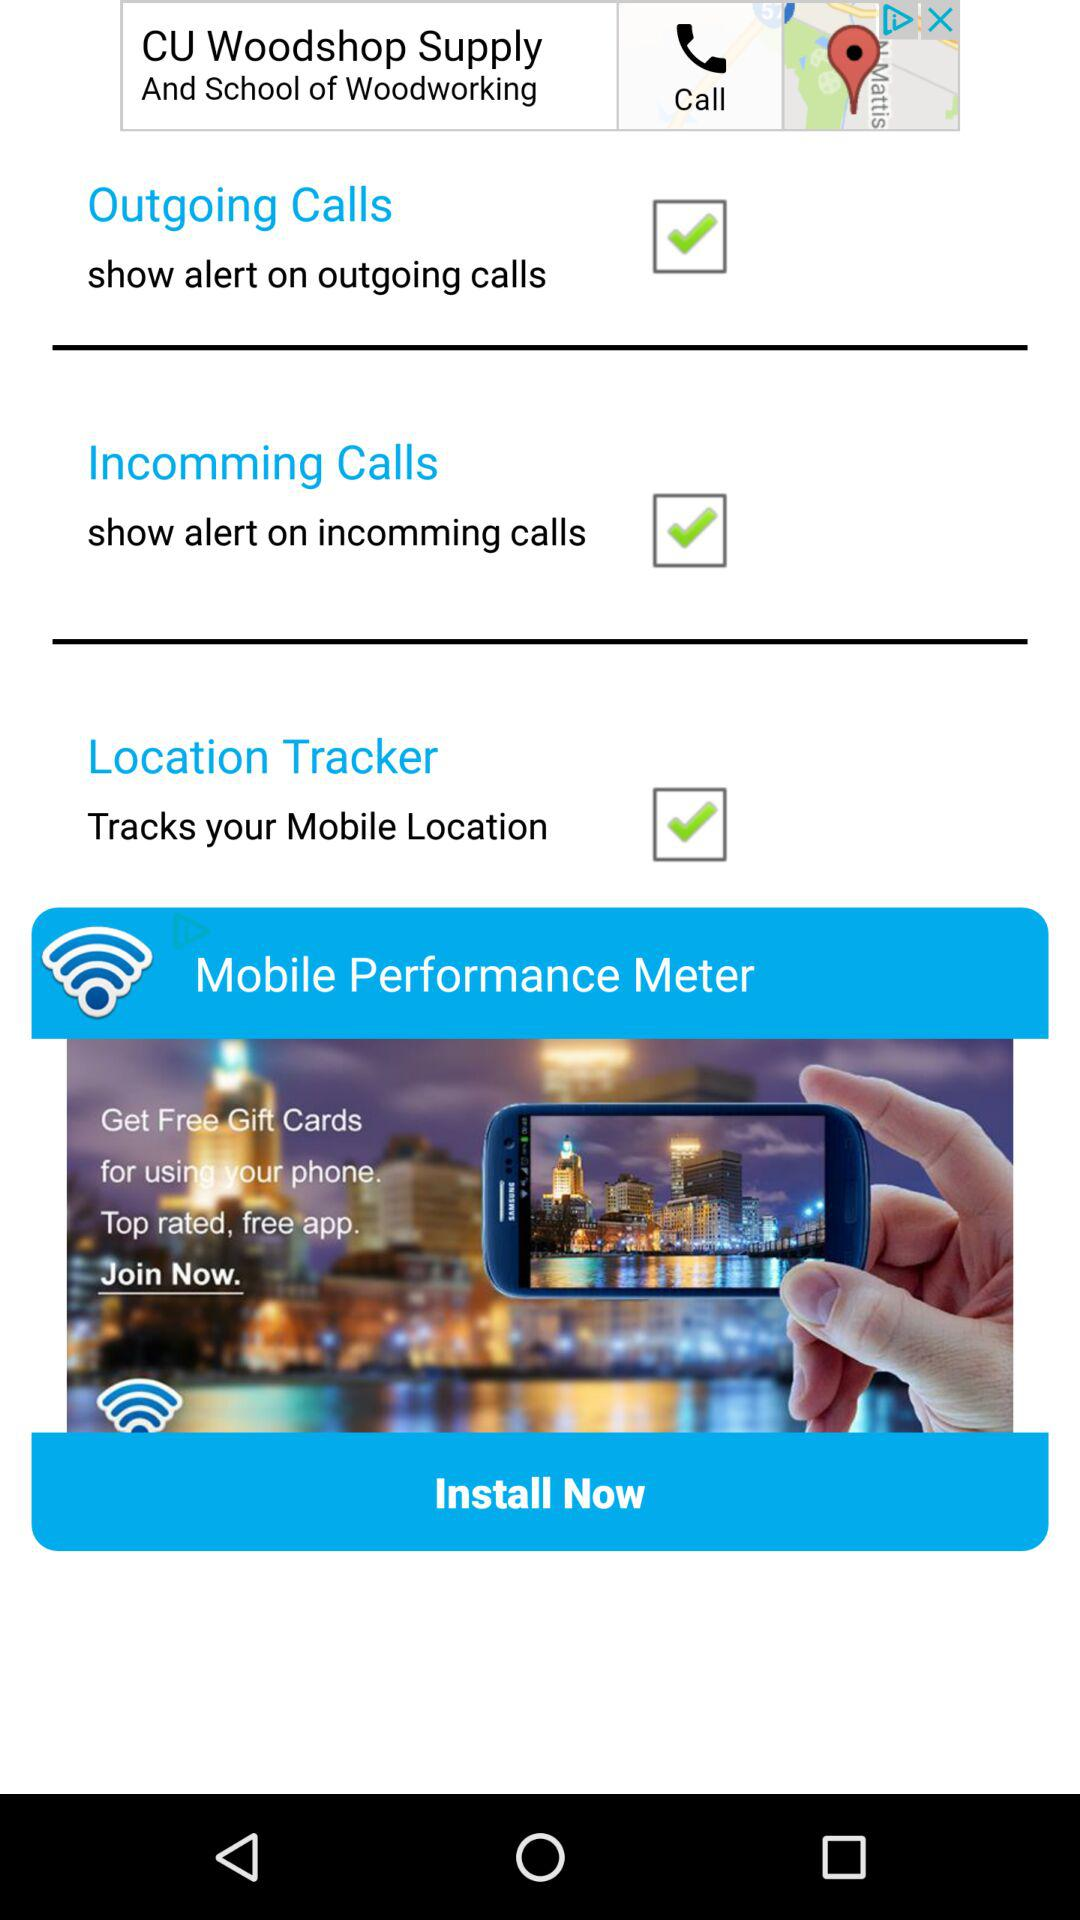Which features are turned on? The features that are turned on are "Outgoing Calls", "Incomming Calls" and "Location Tracker". 